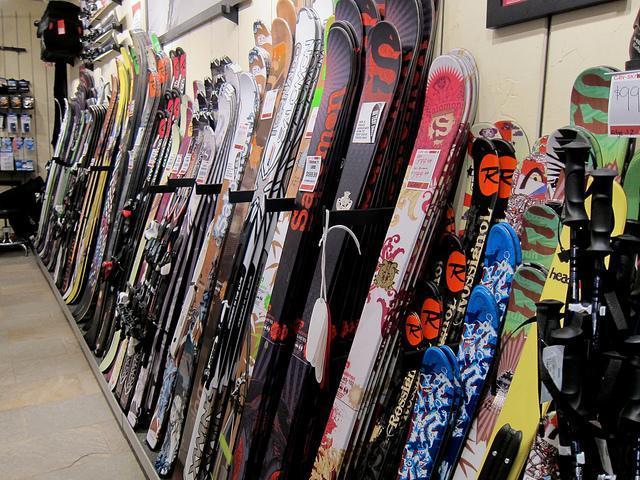How many snowboards are there?
Give a very brief answer. 4. How many ski are in the photo?
Give a very brief answer. 7. 